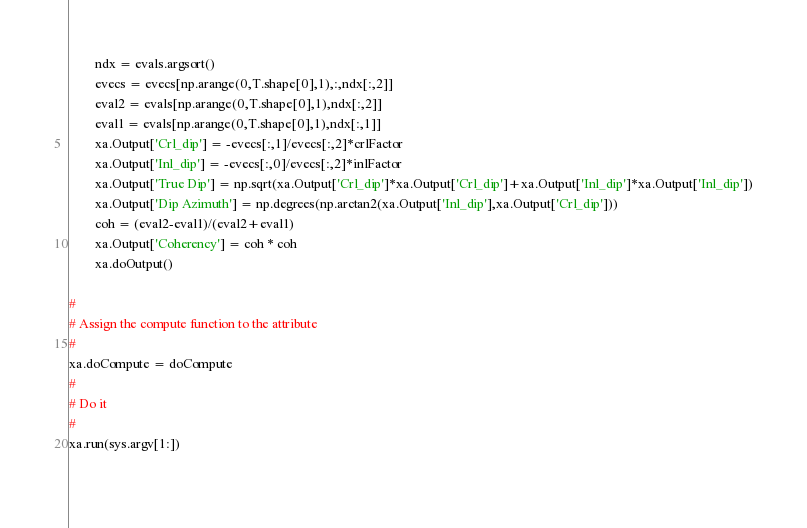Convert code to text. <code><loc_0><loc_0><loc_500><loc_500><_Python_>		ndx = evals.argsort()
		evecs = evecs[np.arange(0,T.shape[0],1),:,ndx[:,2]]
		eval2 = evals[np.arange(0,T.shape[0],1),ndx[:,2]]
		eval1 = evals[np.arange(0,T.shape[0],1),ndx[:,1]]
		xa.Output['Crl_dip'] = -evecs[:,1]/evecs[:,2]*crlFactor
		xa.Output['Inl_dip'] = -evecs[:,0]/evecs[:,2]*inlFactor
		xa.Output['True Dip'] = np.sqrt(xa.Output['Crl_dip']*xa.Output['Crl_dip']+xa.Output['Inl_dip']*xa.Output['Inl_dip'])
		xa.Output['Dip Azimuth'] = np.degrees(np.arctan2(xa.Output['Inl_dip'],xa.Output['Crl_dip']))
		coh = (eval2-eval1)/(eval2+eval1) 
		xa.Output['Coherency'] = coh * coh
		xa.doOutput()
	
#
# Assign the compute function to the attribute
#
xa.doCompute = doCompute
#
# Do it
#
xa.run(sys.argv[1:])
  
</code> 